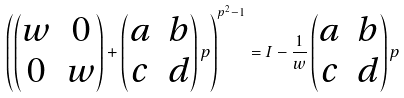Convert formula to latex. <formula><loc_0><loc_0><loc_500><loc_500>\left ( \begin{pmatrix} w & 0 \\ 0 & w \end{pmatrix} + \begin{pmatrix} a & b \\ c & d \end{pmatrix} p \right ) ^ { p ^ { 2 } - 1 } = I - \frac { 1 } { w } \begin{pmatrix} a & b \\ c & d \end{pmatrix} p</formula> 